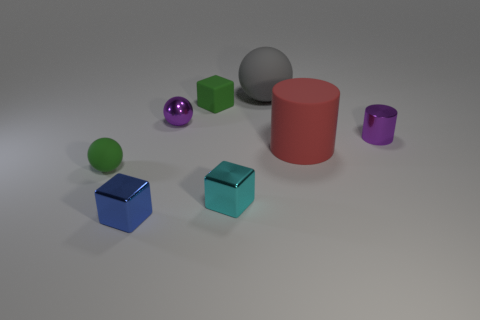Add 2 purple metallic objects. How many objects exist? 10 Subtract all cyan shiny blocks. How many blocks are left? 2 Subtract all cyan blocks. How many blocks are left? 2 Subtract 1 blocks. How many blocks are left? 2 Subtract all spheres. How many objects are left? 5 Add 7 big purple things. How many big purple things exist? 7 Subtract 0 blue spheres. How many objects are left? 8 Subtract all brown cylinders. Subtract all green cubes. How many cylinders are left? 2 Subtract all small green blocks. Subtract all small shiny things. How many objects are left? 3 Add 5 cylinders. How many cylinders are left? 7 